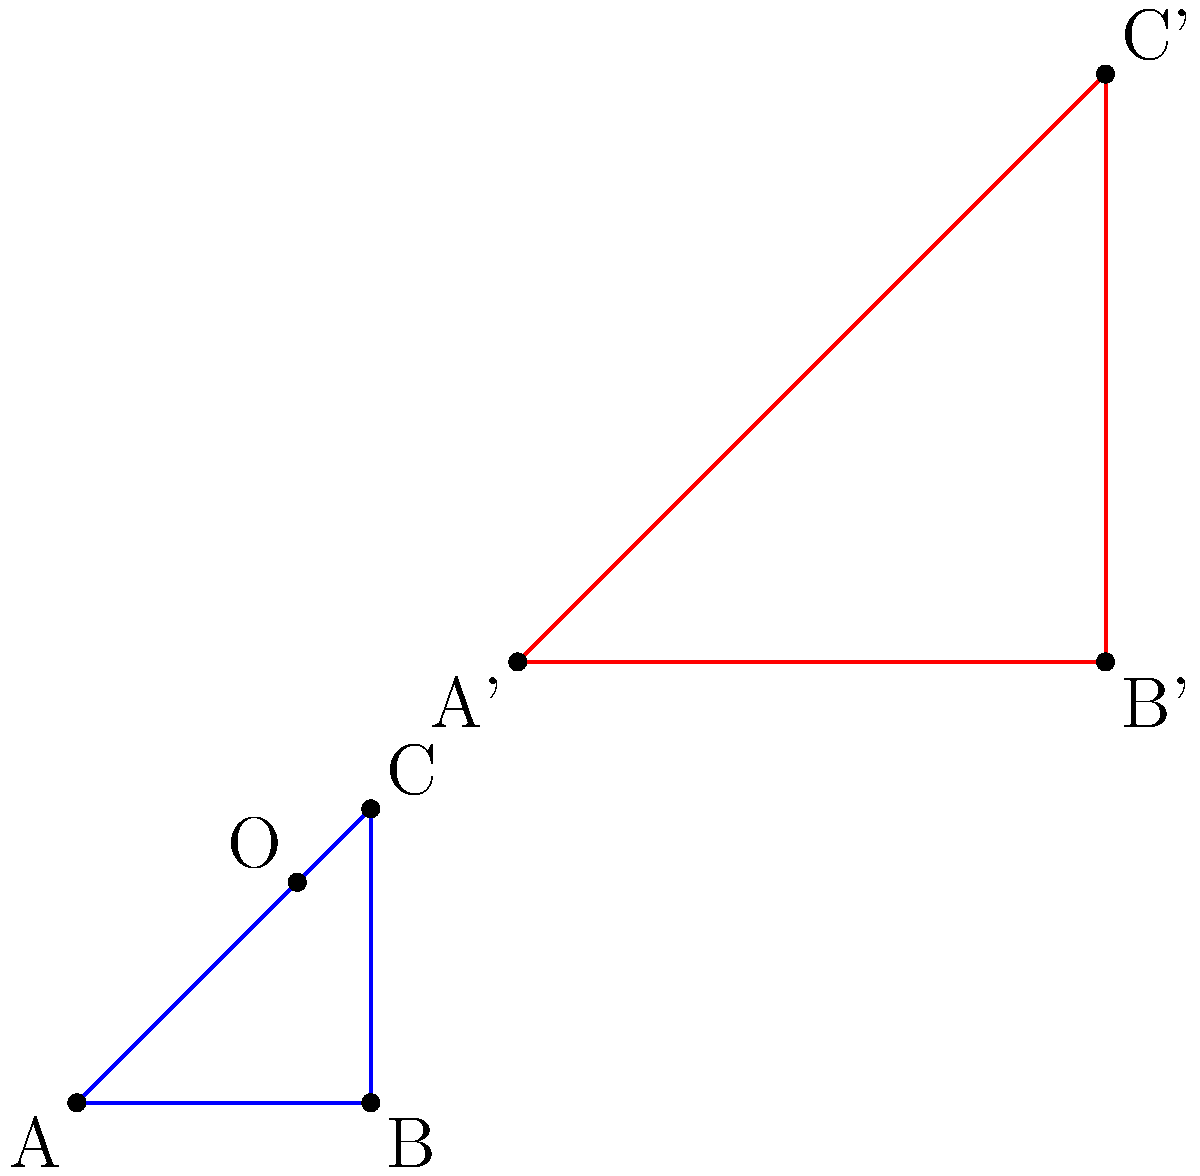In the diagram above, triangle ABC has been dilated to form triangle A'B'C'. Identify the scale factor and center of dilation. How would you explain this concept to seniors learning about digital image manipulation? To find the scale factor and center of dilation, we can follow these steps:

1. Scale factor:
   - Choose a corresponding pair of sides, e.g., AB and A'B'.
   - Measure the length of each side:
     AB = 2 units, A'B' = 4 units
   - Calculate the ratio: $\frac{A'B'}{AB} = \frac{4}{2} = 2$

2. Center of dilation:
   - Draw lines connecting corresponding vertices (A to A', B to B', C to C').
   - These lines should intersect at a single point, which is the center of dilation.
   - In this case, the lines intersect at point O (1.5, 1.5).

3. Verification:
   - Check that $\frac{OA'}{OA} = \frac{OB'}{OB} = \frac{OC'}{OC} = 2$ (the scale factor)

When explaining this to seniors learning digital image manipulation:
- Compare it to resizing an image on a computer.
- The scale factor is like the percentage you increase or decrease an image's size.
- The center of dilation is like the point around which the image grows or shrinks.
- Emphasize that all parts of the image change proportionally, maintaining its shape.
Answer: Scale factor: 2, Center of dilation: (1.5, 1.5) 